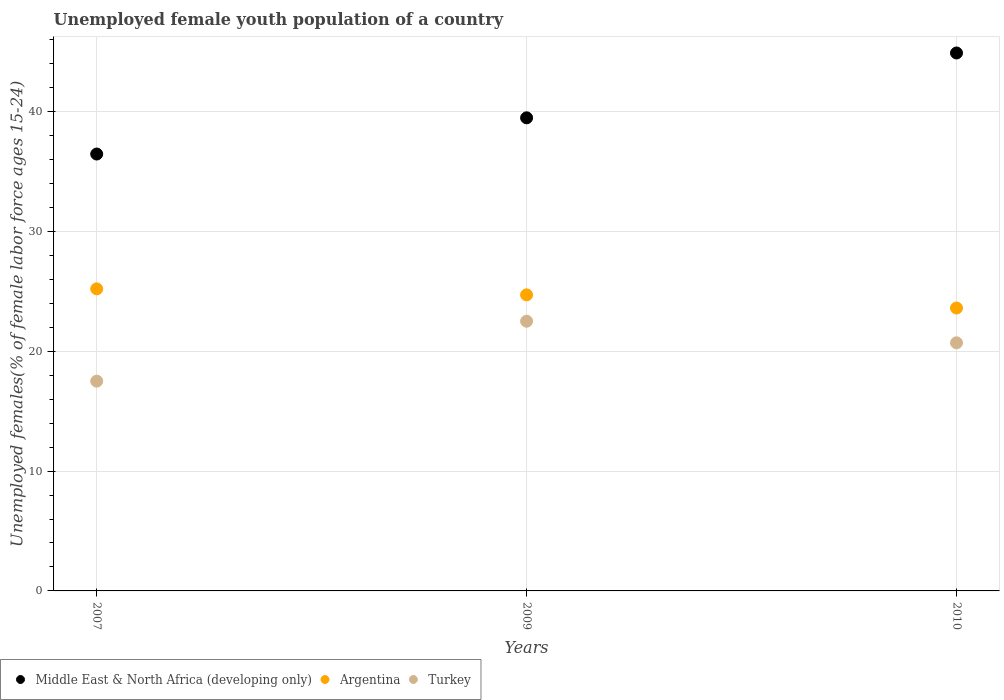How many different coloured dotlines are there?
Keep it short and to the point. 3. What is the percentage of unemployed female youth population in Turkey in 2007?
Ensure brevity in your answer.  17.5. Across all years, what is the minimum percentage of unemployed female youth population in Turkey?
Your answer should be compact. 17.5. In which year was the percentage of unemployed female youth population in Turkey maximum?
Offer a terse response. 2009. In which year was the percentage of unemployed female youth population in Middle East & North Africa (developing only) minimum?
Offer a very short reply. 2007. What is the total percentage of unemployed female youth population in Turkey in the graph?
Your answer should be very brief. 60.7. What is the difference between the percentage of unemployed female youth population in Turkey in 2007 and that in 2010?
Give a very brief answer. -3.2. What is the difference between the percentage of unemployed female youth population in Middle East & North Africa (developing only) in 2010 and the percentage of unemployed female youth population in Argentina in 2009?
Offer a very short reply. 20.18. What is the average percentage of unemployed female youth population in Argentina per year?
Provide a short and direct response. 24.5. In the year 2010, what is the difference between the percentage of unemployed female youth population in Turkey and percentage of unemployed female youth population in Argentina?
Provide a short and direct response. -2.9. In how many years, is the percentage of unemployed female youth population in Middle East & North Africa (developing only) greater than 30 %?
Provide a succinct answer. 3. What is the ratio of the percentage of unemployed female youth population in Middle East & North Africa (developing only) in 2007 to that in 2010?
Make the answer very short. 0.81. Is the difference between the percentage of unemployed female youth population in Turkey in 2007 and 2010 greater than the difference between the percentage of unemployed female youth population in Argentina in 2007 and 2010?
Your answer should be very brief. No. What is the difference between the highest and the second highest percentage of unemployed female youth population in Middle East & North Africa (developing only)?
Make the answer very short. 5.41. What is the difference between the highest and the lowest percentage of unemployed female youth population in Argentina?
Provide a succinct answer. 1.6. Is the percentage of unemployed female youth population in Argentina strictly greater than the percentage of unemployed female youth population in Middle East & North Africa (developing only) over the years?
Your answer should be very brief. No. Is the percentage of unemployed female youth population in Argentina strictly less than the percentage of unemployed female youth population in Middle East & North Africa (developing only) over the years?
Your answer should be very brief. Yes. How many years are there in the graph?
Your answer should be compact. 3. What is the difference between two consecutive major ticks on the Y-axis?
Your answer should be compact. 10. Does the graph contain grids?
Make the answer very short. Yes. What is the title of the graph?
Keep it short and to the point. Unemployed female youth population of a country. Does "Cote d'Ivoire" appear as one of the legend labels in the graph?
Give a very brief answer. No. What is the label or title of the X-axis?
Ensure brevity in your answer.  Years. What is the label or title of the Y-axis?
Provide a succinct answer. Unemployed females(% of female labor force ages 15-24). What is the Unemployed females(% of female labor force ages 15-24) of Middle East & North Africa (developing only) in 2007?
Ensure brevity in your answer.  36.45. What is the Unemployed females(% of female labor force ages 15-24) of Argentina in 2007?
Offer a terse response. 25.2. What is the Unemployed females(% of female labor force ages 15-24) of Turkey in 2007?
Your response must be concise. 17.5. What is the Unemployed females(% of female labor force ages 15-24) in Middle East & North Africa (developing only) in 2009?
Offer a terse response. 39.47. What is the Unemployed females(% of female labor force ages 15-24) in Argentina in 2009?
Your answer should be compact. 24.7. What is the Unemployed females(% of female labor force ages 15-24) of Turkey in 2009?
Give a very brief answer. 22.5. What is the Unemployed females(% of female labor force ages 15-24) in Middle East & North Africa (developing only) in 2010?
Make the answer very short. 44.88. What is the Unemployed females(% of female labor force ages 15-24) in Argentina in 2010?
Keep it short and to the point. 23.6. What is the Unemployed females(% of female labor force ages 15-24) in Turkey in 2010?
Provide a succinct answer. 20.7. Across all years, what is the maximum Unemployed females(% of female labor force ages 15-24) of Middle East & North Africa (developing only)?
Offer a very short reply. 44.88. Across all years, what is the maximum Unemployed females(% of female labor force ages 15-24) in Argentina?
Provide a succinct answer. 25.2. Across all years, what is the maximum Unemployed females(% of female labor force ages 15-24) in Turkey?
Keep it short and to the point. 22.5. Across all years, what is the minimum Unemployed females(% of female labor force ages 15-24) in Middle East & North Africa (developing only)?
Offer a terse response. 36.45. Across all years, what is the minimum Unemployed females(% of female labor force ages 15-24) in Argentina?
Offer a terse response. 23.6. What is the total Unemployed females(% of female labor force ages 15-24) in Middle East & North Africa (developing only) in the graph?
Your answer should be compact. 120.8. What is the total Unemployed females(% of female labor force ages 15-24) in Argentina in the graph?
Your answer should be compact. 73.5. What is the total Unemployed females(% of female labor force ages 15-24) of Turkey in the graph?
Ensure brevity in your answer.  60.7. What is the difference between the Unemployed females(% of female labor force ages 15-24) of Middle East & North Africa (developing only) in 2007 and that in 2009?
Give a very brief answer. -3.02. What is the difference between the Unemployed females(% of female labor force ages 15-24) in Argentina in 2007 and that in 2009?
Keep it short and to the point. 0.5. What is the difference between the Unemployed females(% of female labor force ages 15-24) of Middle East & North Africa (developing only) in 2007 and that in 2010?
Give a very brief answer. -8.43. What is the difference between the Unemployed females(% of female labor force ages 15-24) in Middle East & North Africa (developing only) in 2009 and that in 2010?
Keep it short and to the point. -5.41. What is the difference between the Unemployed females(% of female labor force ages 15-24) in Middle East & North Africa (developing only) in 2007 and the Unemployed females(% of female labor force ages 15-24) in Argentina in 2009?
Your response must be concise. 11.75. What is the difference between the Unemployed females(% of female labor force ages 15-24) of Middle East & North Africa (developing only) in 2007 and the Unemployed females(% of female labor force ages 15-24) of Turkey in 2009?
Offer a very short reply. 13.95. What is the difference between the Unemployed females(% of female labor force ages 15-24) in Argentina in 2007 and the Unemployed females(% of female labor force ages 15-24) in Turkey in 2009?
Your answer should be compact. 2.7. What is the difference between the Unemployed females(% of female labor force ages 15-24) of Middle East & North Africa (developing only) in 2007 and the Unemployed females(% of female labor force ages 15-24) of Argentina in 2010?
Keep it short and to the point. 12.85. What is the difference between the Unemployed females(% of female labor force ages 15-24) of Middle East & North Africa (developing only) in 2007 and the Unemployed females(% of female labor force ages 15-24) of Turkey in 2010?
Your answer should be compact. 15.75. What is the difference between the Unemployed females(% of female labor force ages 15-24) of Middle East & North Africa (developing only) in 2009 and the Unemployed females(% of female labor force ages 15-24) of Argentina in 2010?
Ensure brevity in your answer.  15.87. What is the difference between the Unemployed females(% of female labor force ages 15-24) of Middle East & North Africa (developing only) in 2009 and the Unemployed females(% of female labor force ages 15-24) of Turkey in 2010?
Provide a short and direct response. 18.77. What is the average Unemployed females(% of female labor force ages 15-24) of Middle East & North Africa (developing only) per year?
Offer a very short reply. 40.27. What is the average Unemployed females(% of female labor force ages 15-24) of Argentina per year?
Provide a succinct answer. 24.5. What is the average Unemployed females(% of female labor force ages 15-24) of Turkey per year?
Provide a succinct answer. 20.23. In the year 2007, what is the difference between the Unemployed females(% of female labor force ages 15-24) of Middle East & North Africa (developing only) and Unemployed females(% of female labor force ages 15-24) of Argentina?
Offer a terse response. 11.25. In the year 2007, what is the difference between the Unemployed females(% of female labor force ages 15-24) of Middle East & North Africa (developing only) and Unemployed females(% of female labor force ages 15-24) of Turkey?
Give a very brief answer. 18.95. In the year 2007, what is the difference between the Unemployed females(% of female labor force ages 15-24) in Argentina and Unemployed females(% of female labor force ages 15-24) in Turkey?
Offer a terse response. 7.7. In the year 2009, what is the difference between the Unemployed females(% of female labor force ages 15-24) in Middle East & North Africa (developing only) and Unemployed females(% of female labor force ages 15-24) in Argentina?
Offer a very short reply. 14.77. In the year 2009, what is the difference between the Unemployed females(% of female labor force ages 15-24) of Middle East & North Africa (developing only) and Unemployed females(% of female labor force ages 15-24) of Turkey?
Offer a terse response. 16.97. In the year 2010, what is the difference between the Unemployed females(% of female labor force ages 15-24) in Middle East & North Africa (developing only) and Unemployed females(% of female labor force ages 15-24) in Argentina?
Provide a succinct answer. 21.28. In the year 2010, what is the difference between the Unemployed females(% of female labor force ages 15-24) in Middle East & North Africa (developing only) and Unemployed females(% of female labor force ages 15-24) in Turkey?
Offer a terse response. 24.18. In the year 2010, what is the difference between the Unemployed females(% of female labor force ages 15-24) of Argentina and Unemployed females(% of female labor force ages 15-24) of Turkey?
Keep it short and to the point. 2.9. What is the ratio of the Unemployed females(% of female labor force ages 15-24) in Middle East & North Africa (developing only) in 2007 to that in 2009?
Provide a succinct answer. 0.92. What is the ratio of the Unemployed females(% of female labor force ages 15-24) of Argentina in 2007 to that in 2009?
Offer a terse response. 1.02. What is the ratio of the Unemployed females(% of female labor force ages 15-24) in Turkey in 2007 to that in 2009?
Offer a very short reply. 0.78. What is the ratio of the Unemployed females(% of female labor force ages 15-24) in Middle East & North Africa (developing only) in 2007 to that in 2010?
Ensure brevity in your answer.  0.81. What is the ratio of the Unemployed females(% of female labor force ages 15-24) in Argentina in 2007 to that in 2010?
Offer a terse response. 1.07. What is the ratio of the Unemployed females(% of female labor force ages 15-24) of Turkey in 2007 to that in 2010?
Provide a succinct answer. 0.85. What is the ratio of the Unemployed females(% of female labor force ages 15-24) of Middle East & North Africa (developing only) in 2009 to that in 2010?
Offer a terse response. 0.88. What is the ratio of the Unemployed females(% of female labor force ages 15-24) of Argentina in 2009 to that in 2010?
Ensure brevity in your answer.  1.05. What is the ratio of the Unemployed females(% of female labor force ages 15-24) of Turkey in 2009 to that in 2010?
Offer a very short reply. 1.09. What is the difference between the highest and the second highest Unemployed females(% of female labor force ages 15-24) of Middle East & North Africa (developing only)?
Make the answer very short. 5.41. What is the difference between the highest and the second highest Unemployed females(% of female labor force ages 15-24) of Argentina?
Provide a succinct answer. 0.5. What is the difference between the highest and the second highest Unemployed females(% of female labor force ages 15-24) in Turkey?
Ensure brevity in your answer.  1.8. What is the difference between the highest and the lowest Unemployed females(% of female labor force ages 15-24) of Middle East & North Africa (developing only)?
Your response must be concise. 8.43. What is the difference between the highest and the lowest Unemployed females(% of female labor force ages 15-24) of Argentina?
Offer a terse response. 1.6. 